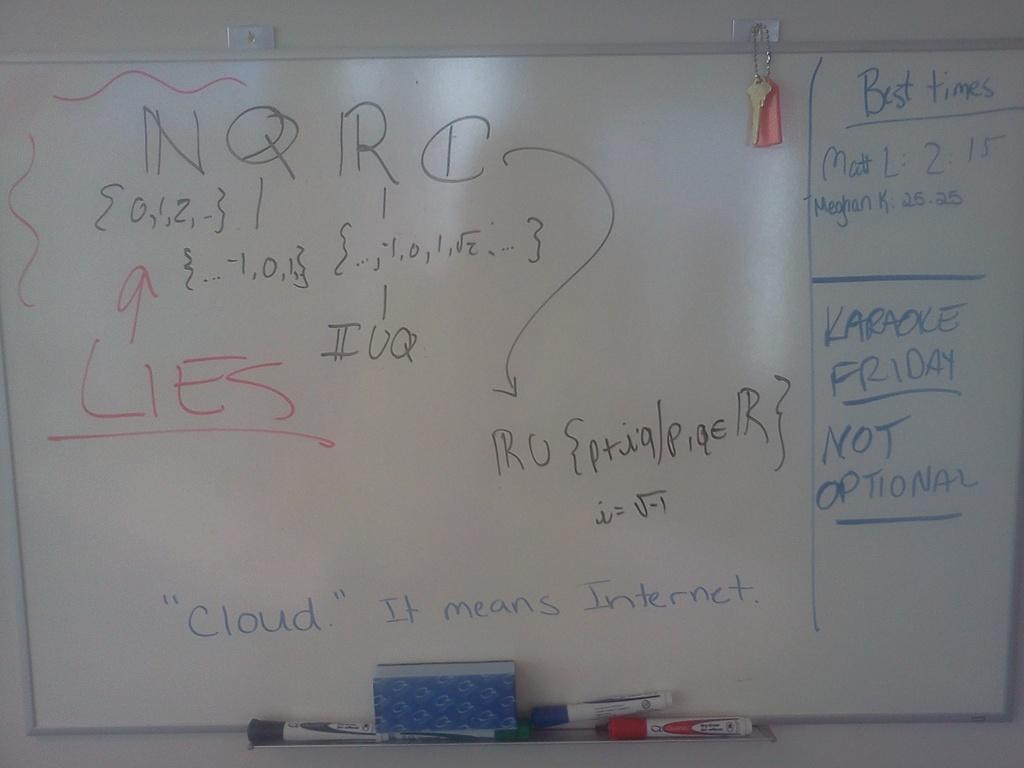<image>
Give a short and clear explanation of the subsequent image. The best time shown for Matt L is 2.15. 